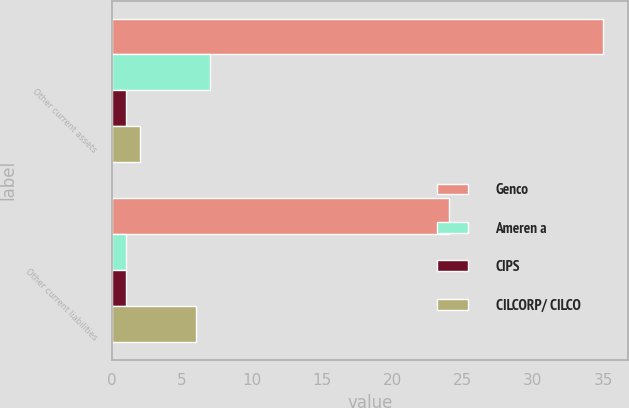Convert chart to OTSL. <chart><loc_0><loc_0><loc_500><loc_500><stacked_bar_chart><ecel><fcel>Other current assets<fcel>Other current liabilities<nl><fcel>Genco<fcel>35<fcel>24<nl><fcel>Ameren a<fcel>7<fcel>1<nl><fcel>CIPS<fcel>1<fcel>1<nl><fcel>CILCORP/ CILCO<fcel>2<fcel>6<nl></chart> 